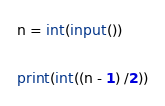Convert code to text. <code><loc_0><loc_0><loc_500><loc_500><_Python_>n = int(input())

print(int((n - 1) /2))
</code> 